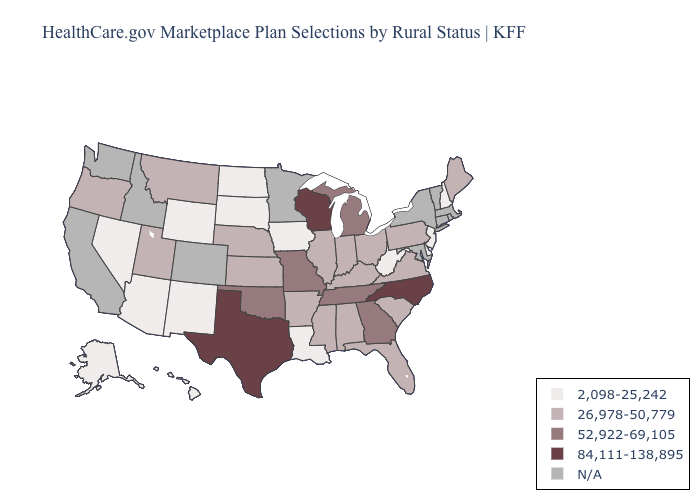What is the value of Kentucky?
Give a very brief answer. 26,978-50,779. What is the value of Mississippi?
Answer briefly. 26,978-50,779. Name the states that have a value in the range 52,922-69,105?
Give a very brief answer. Georgia, Michigan, Missouri, Oklahoma, Tennessee. Name the states that have a value in the range 2,098-25,242?
Give a very brief answer. Alaska, Arizona, Delaware, Hawaii, Iowa, Louisiana, Nevada, New Hampshire, New Jersey, New Mexico, North Dakota, South Dakota, West Virginia, Wyoming. What is the lowest value in states that border Nebraska?
Be succinct. 2,098-25,242. What is the lowest value in states that border Illinois?
Be succinct. 2,098-25,242. Does the map have missing data?
Concise answer only. Yes. Among the states that border Tennessee , does Arkansas have the highest value?
Short answer required. No. Name the states that have a value in the range N/A?
Answer briefly. California, Colorado, Connecticut, Idaho, Maryland, Massachusetts, Minnesota, New York, Rhode Island, Vermont, Washington. What is the lowest value in states that border Vermont?
Give a very brief answer. 2,098-25,242. Which states have the lowest value in the USA?
Answer briefly. Alaska, Arizona, Delaware, Hawaii, Iowa, Louisiana, Nevada, New Hampshire, New Jersey, New Mexico, North Dakota, South Dakota, West Virginia, Wyoming. Does Iowa have the highest value in the MidWest?
Answer briefly. No. What is the highest value in states that border Arizona?
Give a very brief answer. 26,978-50,779. What is the highest value in states that border New Mexico?
Keep it brief. 84,111-138,895. Name the states that have a value in the range 52,922-69,105?
Give a very brief answer. Georgia, Michigan, Missouri, Oklahoma, Tennessee. 